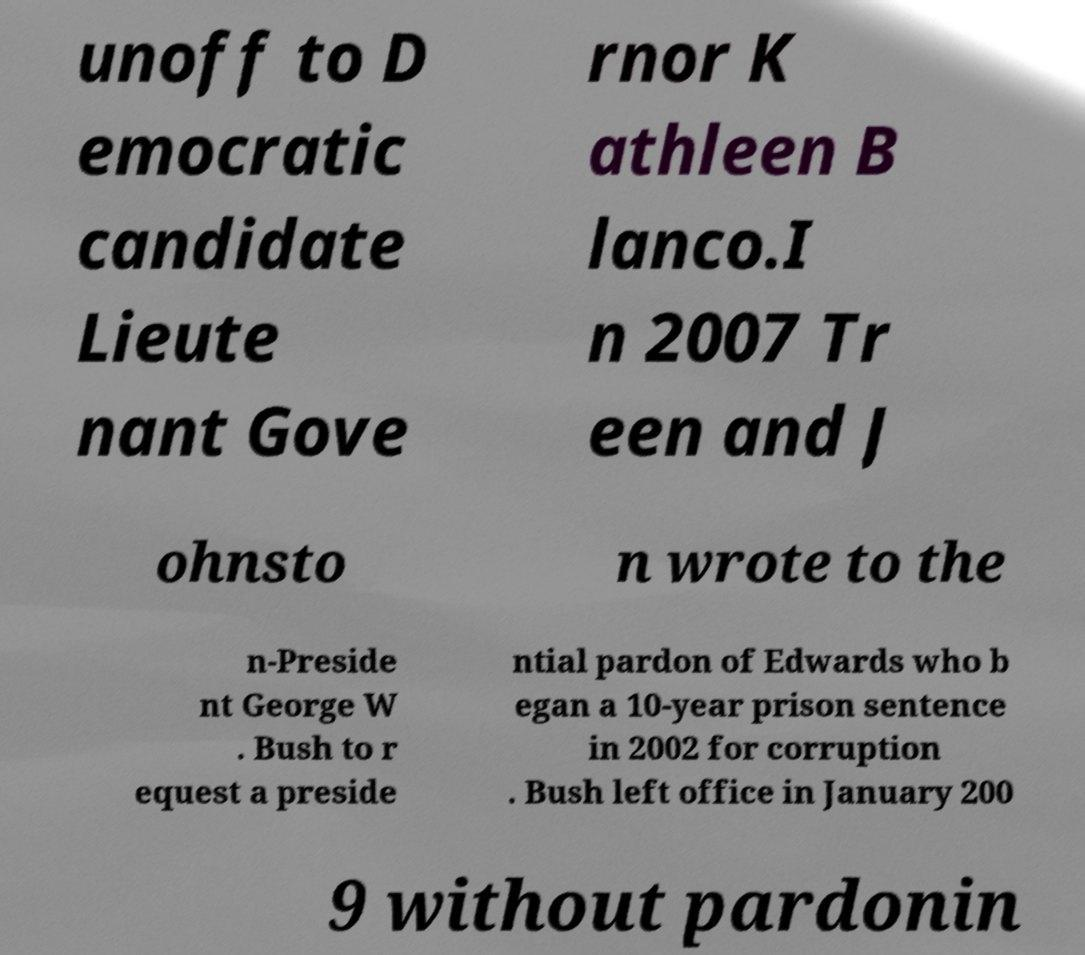I need the written content from this picture converted into text. Can you do that? unoff to D emocratic candidate Lieute nant Gove rnor K athleen B lanco.I n 2007 Tr een and J ohnsto n wrote to the n-Preside nt George W . Bush to r equest a preside ntial pardon of Edwards who b egan a 10-year prison sentence in 2002 for corruption . Bush left office in January 200 9 without pardonin 